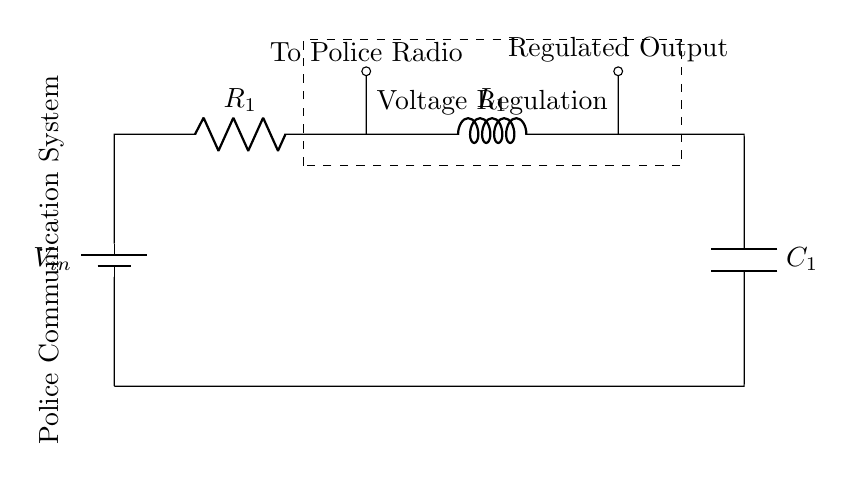What is the input voltage in the circuit? The input voltage is labeled as V_in in the circuit diagram, which is marked next to the battery symbol.
Answer: V_in What component directly connects to the police radio? The component that directly connects to the police radio is the resistor labeled R_1, which is situated in series before the regulated output connection.
Answer: R_1 What is the function of C_1 in this circuit? C_1 is a capacitor, and its function in this voltage regulation circuit is to store and filter voltage, smoothing out the fluctuations and providing a stable voltage to the output.
Answer: Filtering Which components are part of the voltage regulation section of the circuit? The voltage regulation section includes R_1 (resistor), L_1 (inductor), and C_1 (capacitor) as they work together to regulate and control the voltage supplied to the police radio.
Answer: R_1, L_1, C_1 If the current through R_1 increases, what happens to the voltage across C_1? If the current through R_1 increases, it influences the voltage drop across R_1, which can lead to a lower voltage across C_1 due to the series configuration, resulting in reduced output voltage.
Answer: Decreases Why is inductance important in this regulation circuit? Inductance is important because L_1 helps to store energy and resist changes in current, smoothing out voltage fluctuations and providing a more stable output for the police communication system.
Answer: Stability 